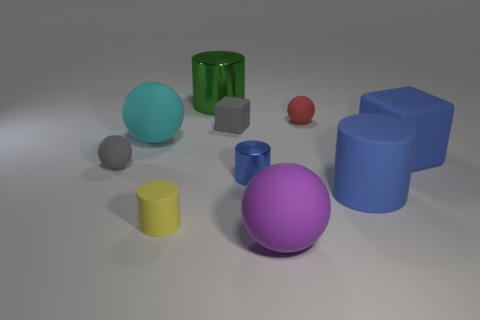Are there fewer big purple spheres behind the big metallic cylinder than tiny red spheres? Indeed, if we examine the scene carefully, behind the large metallic cylinder, we can observe only one large purple sphere, whereas in the general vicinity, there appear to be two small red spheres. Therefore, there are fewer large purple spheres behind the cylinder than tiny red spheres. 